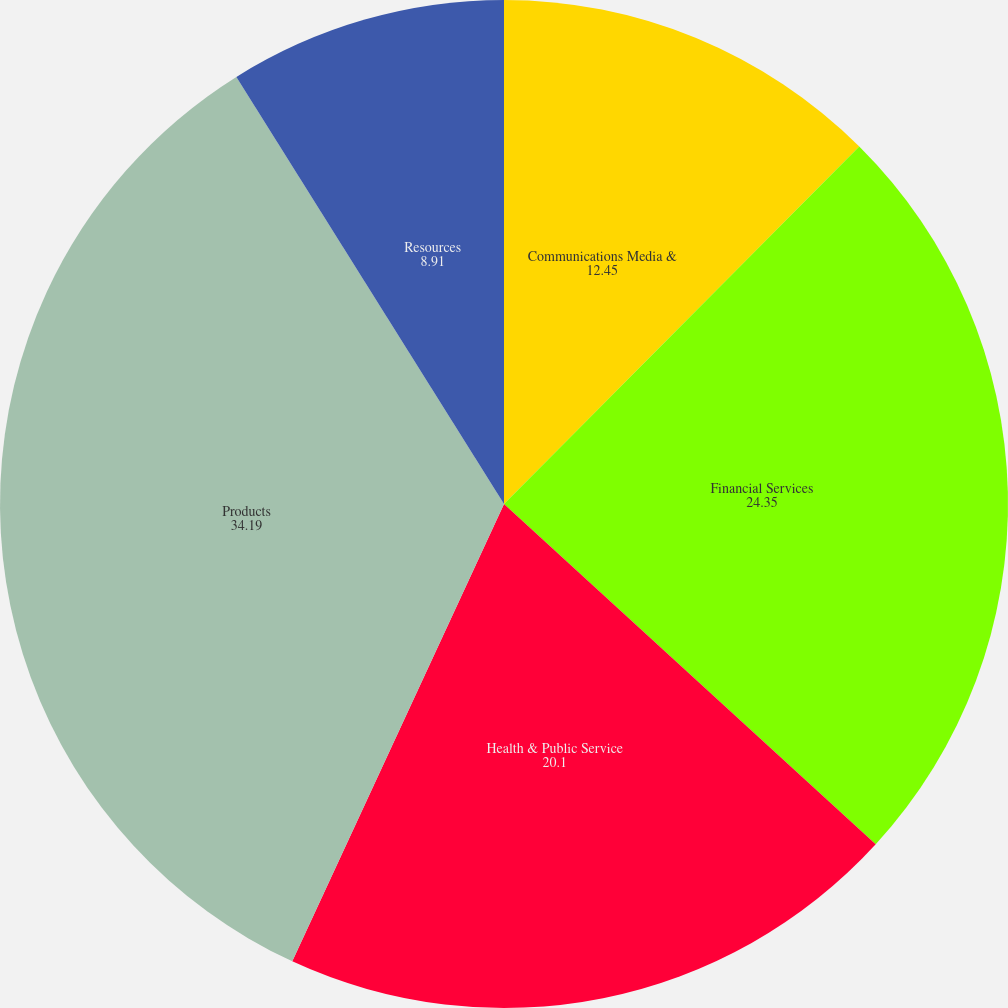Convert chart to OTSL. <chart><loc_0><loc_0><loc_500><loc_500><pie_chart><fcel>Communications Media &<fcel>Financial Services<fcel>Health & Public Service<fcel>Products<fcel>Resources<nl><fcel>12.45%<fcel>24.35%<fcel>20.1%<fcel>34.19%<fcel>8.91%<nl></chart> 